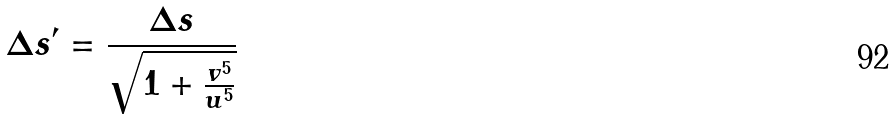Convert formula to latex. <formula><loc_0><loc_0><loc_500><loc_500>\Delta s ^ { \prime } = \frac { \Delta s } { \sqrt { 1 + \frac { v ^ { 5 } } { u ^ { 5 } } } }</formula> 